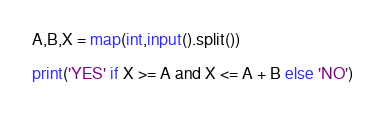<code> <loc_0><loc_0><loc_500><loc_500><_Python_>A,B,X = map(int,input().split())

print('YES' if X >= A and X <= A + B else 'NO')
</code> 